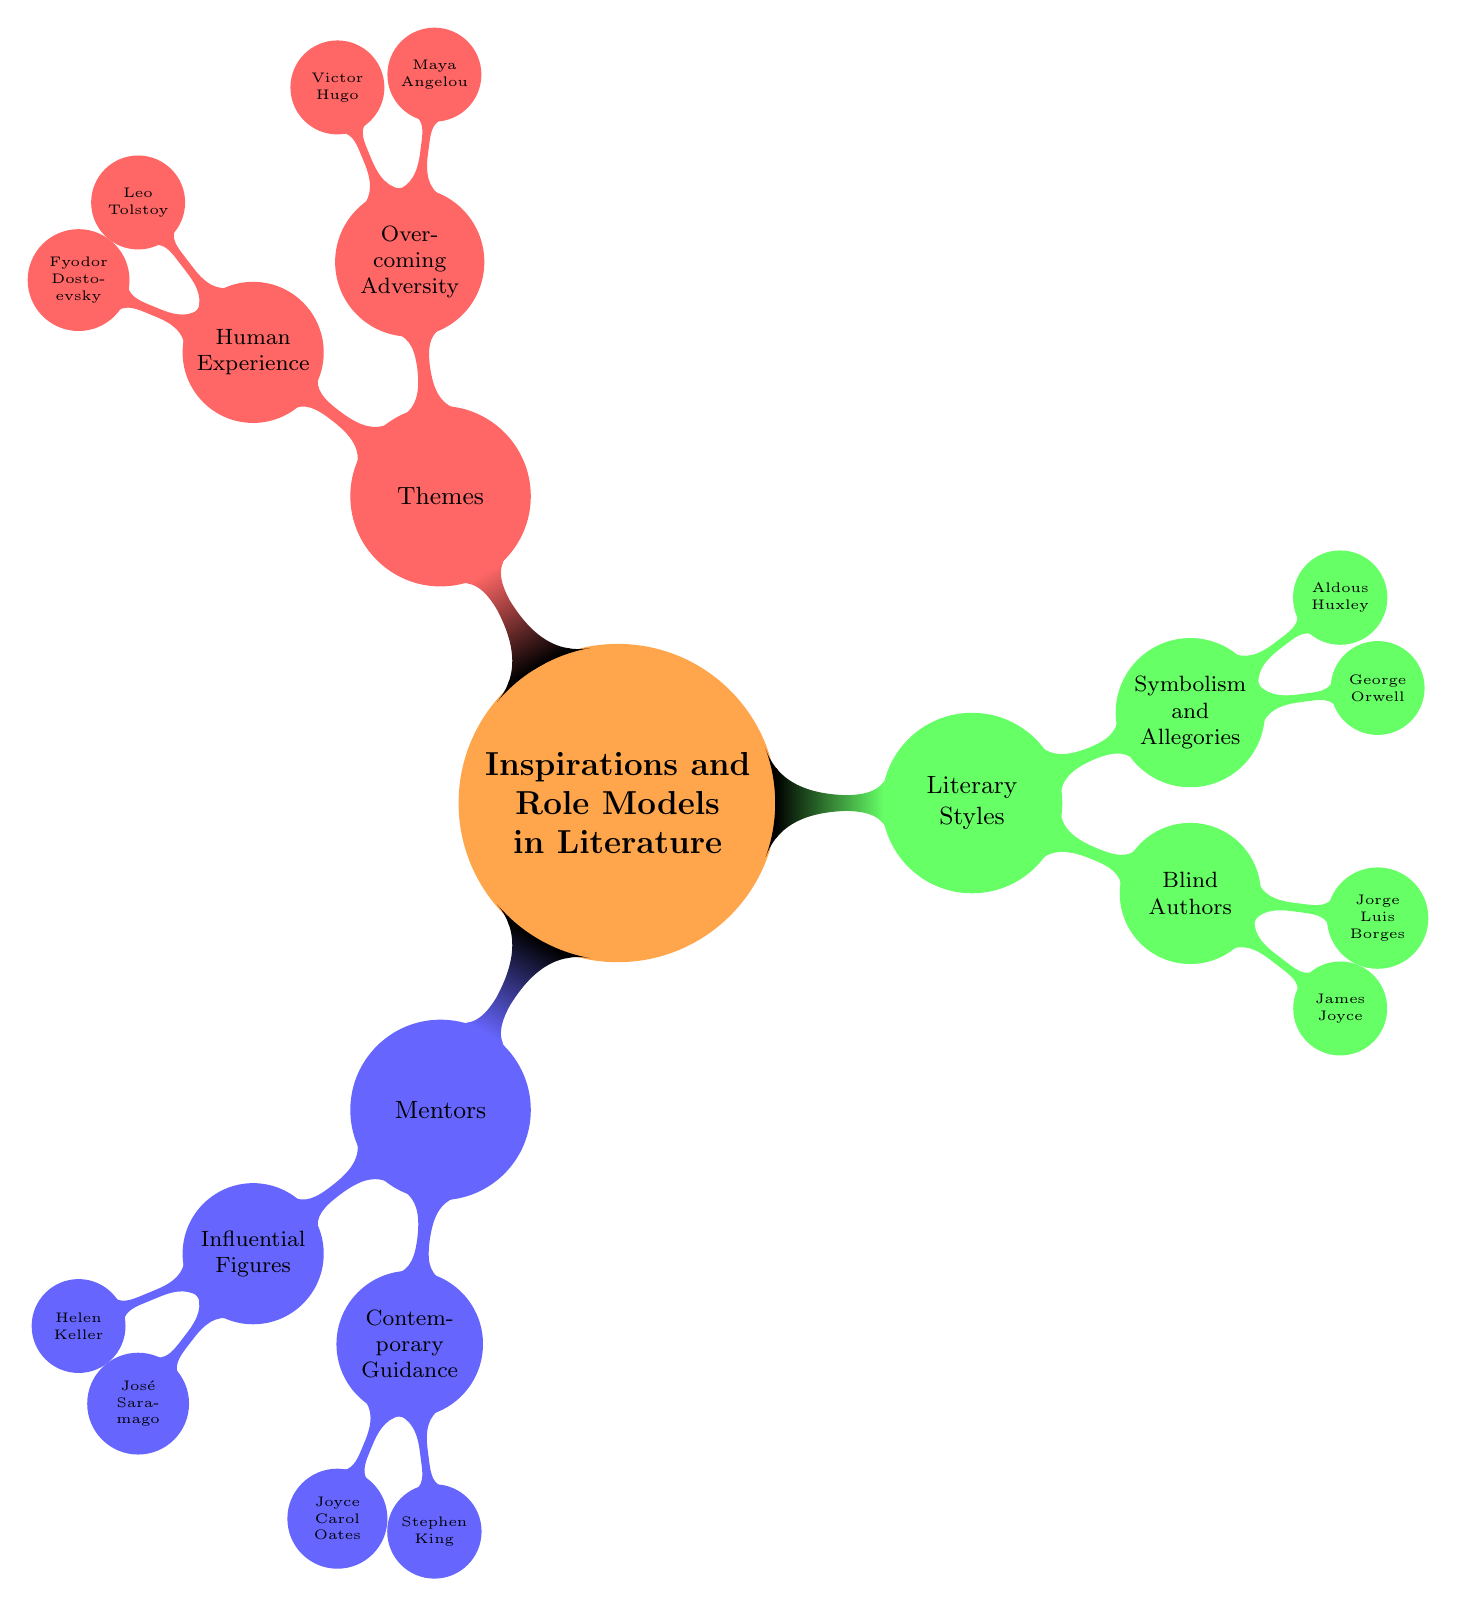What are the two categories under Mentors? The diagram lists two categories under Mentors: "Influential Figures" and "Contemporary Guidance". This is derived from the first main branch under the central topic, showing how the concept is organized into two subcategories.
Answer: Influential Figures, Contemporary Guidance Who is listed under Blind Authors? In the diagram, the category "Blind Authors" lists two individuals: James Joyce and Jorge Luis Borges. This can be found directly as a sub-node under the broader category of Literary Styles, answering the question about who is associated with being blind authors.
Answer: James Joyce, Jorge Luis Borges How many authors are mentioned under Themes? The diagram specifies four authors mentioned under the "Themes" category: Maya Angelou, Victor Hugo, Leo Tolstoy, and Fyodor Dostoevsky. By counting these names in the respective sub-nodes, we find the total number of authors in this section.
Answer: 4 Which authors are associated with Overcoming Adversity? The diagram indicates that Maya Angelou and Victor Hugo are associated with the theme of Overcoming Adversity. This can be found in the designated sub-node beneath the "Themes" category for this specific theme.
Answer: Maya Angelou, Victor Hugo Name one influential figure under Mentors. The sub-node labeled "Influential Figures" under Mentors includes Helen Keller and José Saramago. As the question asks for one influential figure, either name would satisfy the query, but we can specify one for clarity.
Answer: Helen Keller What relationship can be inferred between the Blind Authors and Literary Styles? The diagram connects "Blind Authors" as a sub-category under "Literary Styles", indicating that these authors are categorized specifically by their literary styles despite their visual impairments. This node organizational structure highlights a thematic relationship between blindness and certain literary contributions.
Answer: They are a sub-category under Literary Styles Which theme includes Leo Tolstoy? In the mind map, Leo Tolstoy is mentioned explicitly in the "Human Experience" section of the "Themes" category. By locating his name in the appropriate sub-node, we can confirm the connection.
Answer: Human Experience How many authors are assigned to Symbolism and Allegories? According to the diagram, the category "Symbolism and Allegories" has two authors listed: George Orwell and Aldous Huxley. This count comes directly from the visual representation under Literary Styles for that specific theme.
Answer: 2 